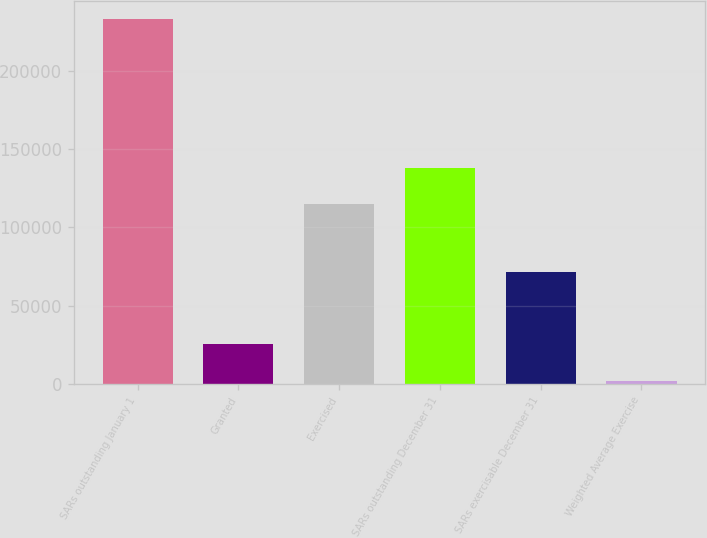<chart> <loc_0><loc_0><loc_500><loc_500><bar_chart><fcel>SARs outstanding January 1<fcel>Granted<fcel>Exercised<fcel>SARs outstanding December 31<fcel>SARs exercisable December 31<fcel>Weighted Average Exercise<nl><fcel>232930<fcel>25107.4<fcel>114976<fcel>138067<fcel>71701<fcel>2016<nl></chart> 